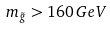Convert formula to latex. <formula><loc_0><loc_0><loc_500><loc_500>m _ { \tilde { g } } > 1 6 0 \, G e V</formula> 